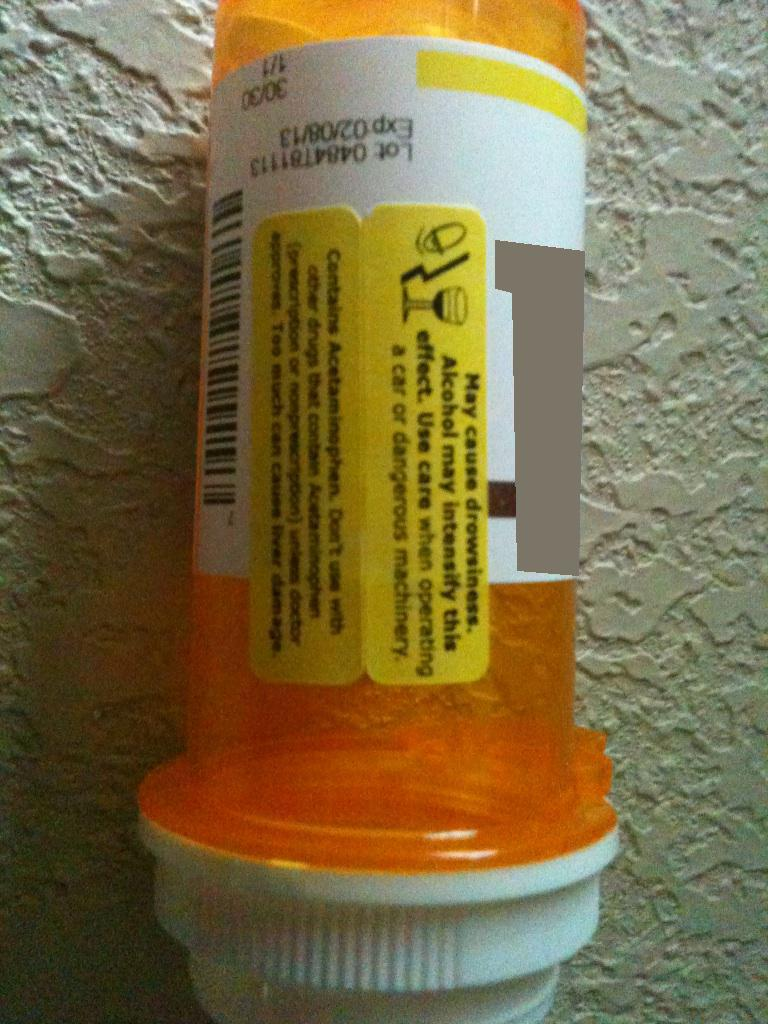What kind of precautions should one take after reading this warning label? After reading the warning label, one should avoid consuming alcohol due to the increased risk of drowsiness and operate machinery or drive with caution. It's also crucial not to exceed the recommended dosage because too much acetaminophen can lead to severe liver damage. Additionally, one should avoid taking other medications that contain acetaminophen to prevent overdose. 